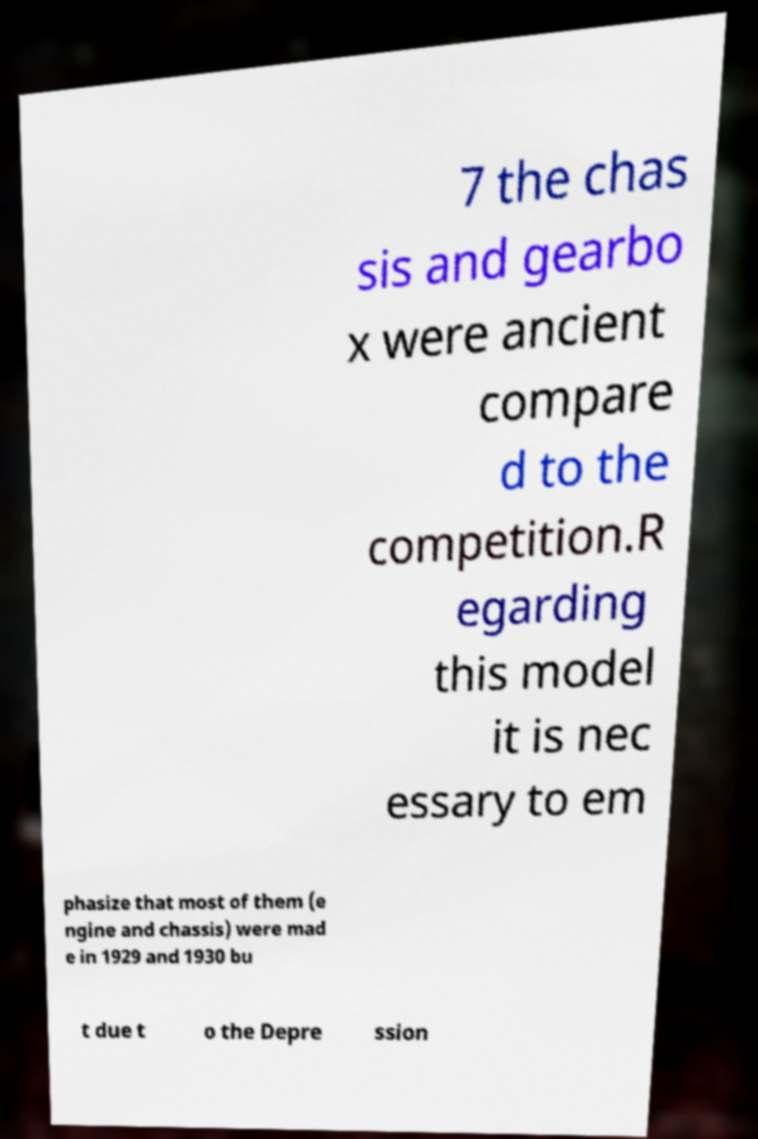Please read and relay the text visible in this image. What does it say? 7 the chas sis and gearbo x were ancient compare d to the competition.R egarding this model it is nec essary to em phasize that most of them (e ngine and chassis) were mad e in 1929 and 1930 bu t due t o the Depre ssion 